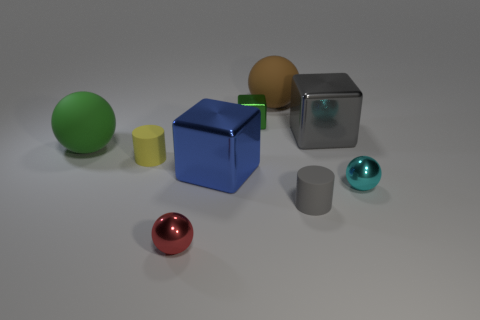There is a metallic block that is in front of the rubber cylinder to the left of the tiny green block; how big is it?
Offer a very short reply. Large. What color is the cube that is left of the gray matte object and behind the big green rubber thing?
Make the answer very short. Green. There is a cube that is the same size as the cyan object; what is its material?
Your answer should be very brief. Metal. What number of other objects are there of the same material as the gray block?
Your response must be concise. 4. There is a object left of the yellow cylinder; is it the same color as the small matte object that is on the left side of the red metallic thing?
Provide a short and direct response. No. There is a shiny object in front of the metallic sphere that is behind the gray rubber cylinder; what is its shape?
Give a very brief answer. Sphere. What number of other objects are the same color as the tiny block?
Offer a very short reply. 1. Is the material of the small ball to the right of the green cube the same as the tiny yellow cylinder behind the tiny red object?
Keep it short and to the point. No. There is a object that is right of the large gray shiny thing; what is its size?
Provide a short and direct response. Small. What material is the gray thing that is the same shape as the yellow thing?
Your response must be concise. Rubber. 